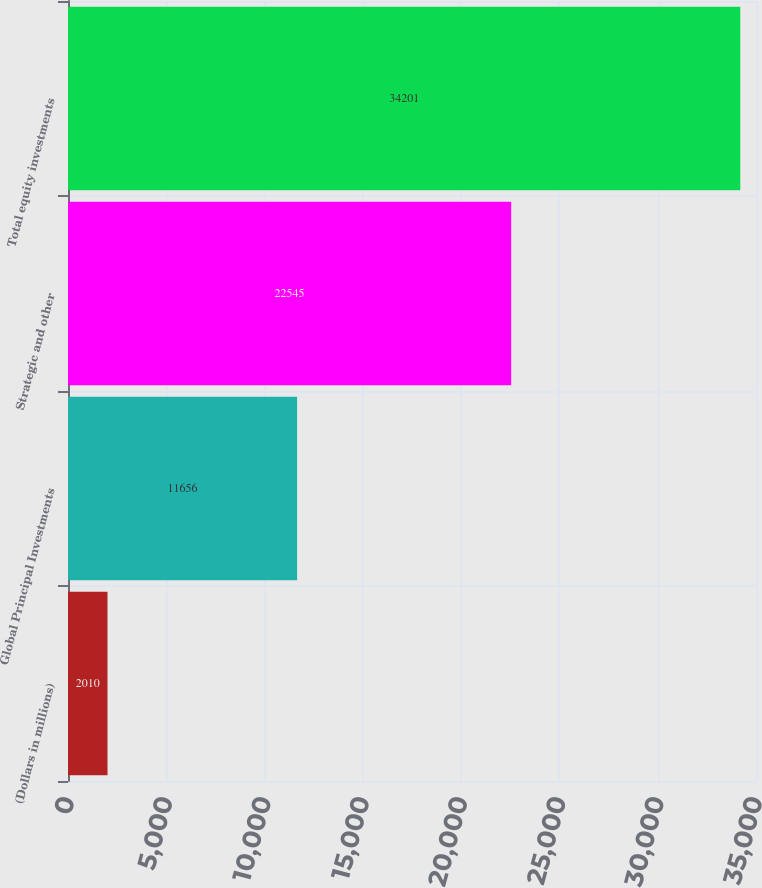Convert chart to OTSL. <chart><loc_0><loc_0><loc_500><loc_500><bar_chart><fcel>(Dollars in millions)<fcel>Global Principal Investments<fcel>Strategic and other<fcel>Total equity investments<nl><fcel>2010<fcel>11656<fcel>22545<fcel>34201<nl></chart> 